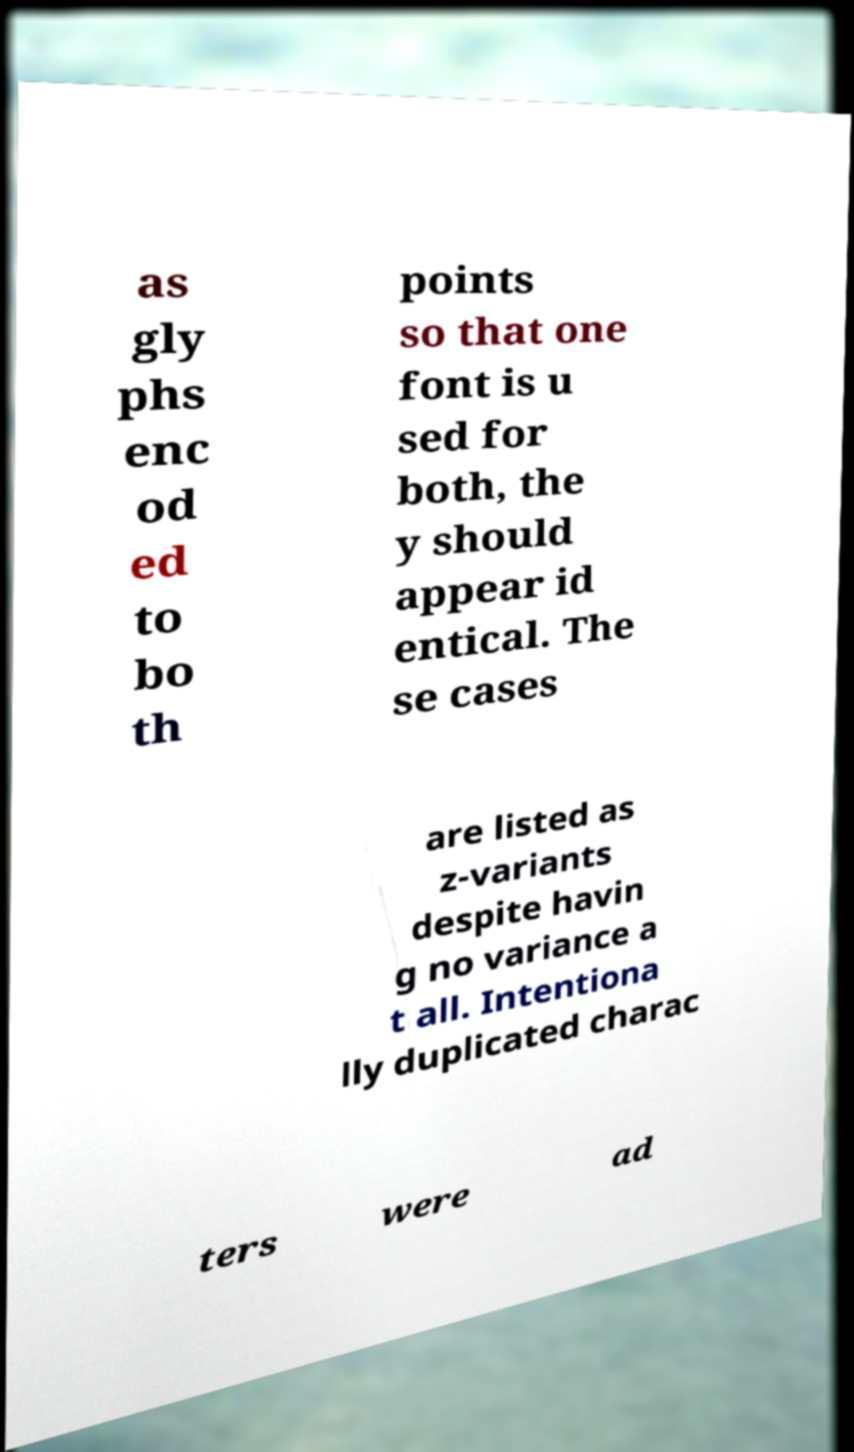I need the written content from this picture converted into text. Can you do that? as gly phs enc od ed to bo th points so that one font is u sed for both, the y should appear id entical. The se cases are listed as z-variants despite havin g no variance a t all. Intentiona lly duplicated charac ters were ad 